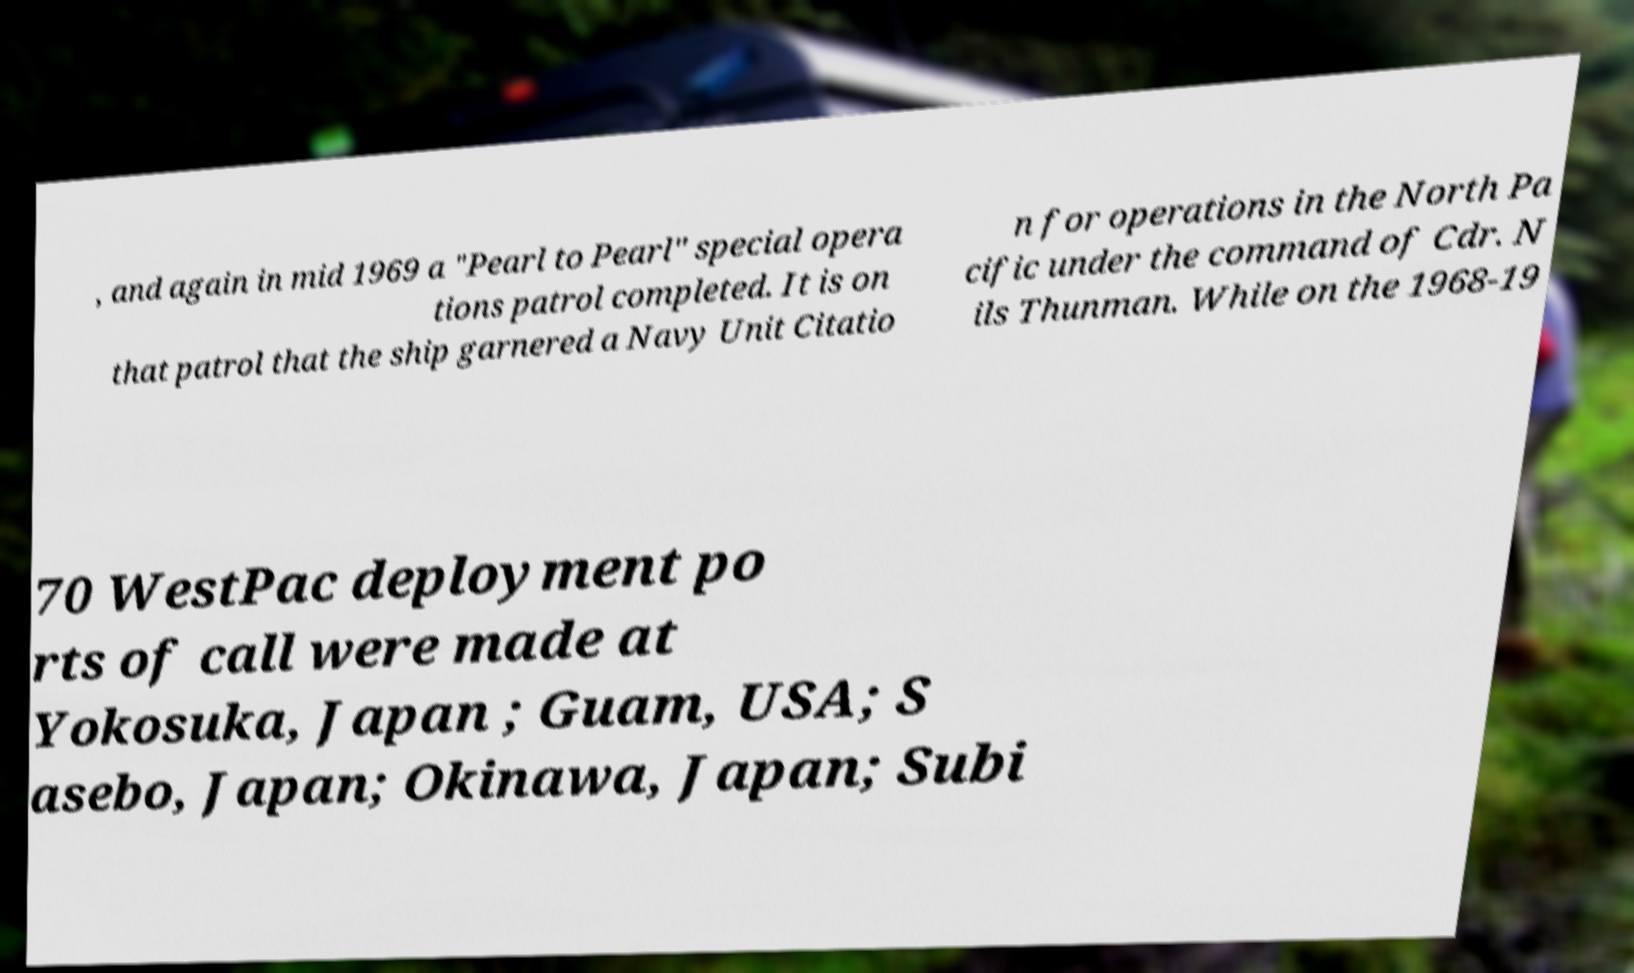Can you read and provide the text displayed in the image?This photo seems to have some interesting text. Can you extract and type it out for me? , and again in mid 1969 a "Pearl to Pearl" special opera tions patrol completed. It is on that patrol that the ship garnered a Navy Unit Citatio n for operations in the North Pa cific under the command of Cdr. N ils Thunman. While on the 1968-19 70 WestPac deployment po rts of call were made at Yokosuka, Japan ; Guam, USA; S asebo, Japan; Okinawa, Japan; Subi 